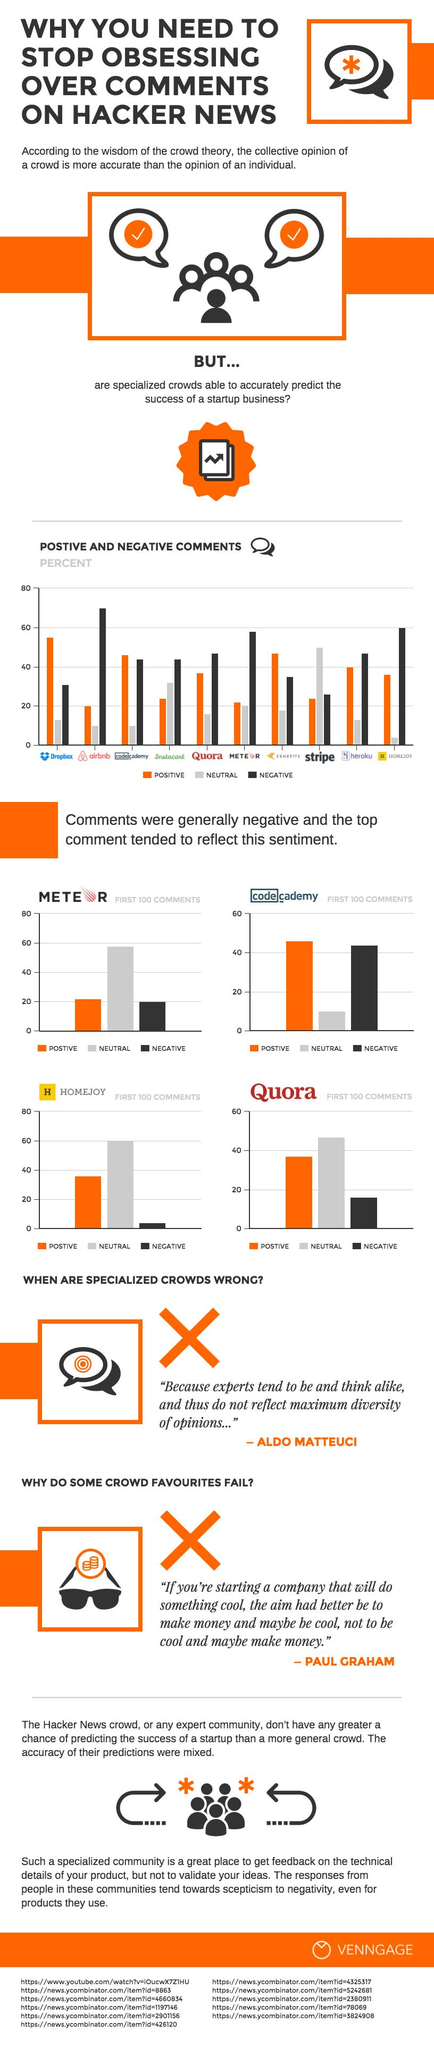Give some essential details in this illustration. I declare that HOMEJOY was the website that received the least negative comments within the first 100 comments. The website with the second highest percentage of negative comments was HOMEJOY. The first 100 comments for Codecademy were mainly positive in nature. Approximately 70% of the comments about Airbnb were negative. 